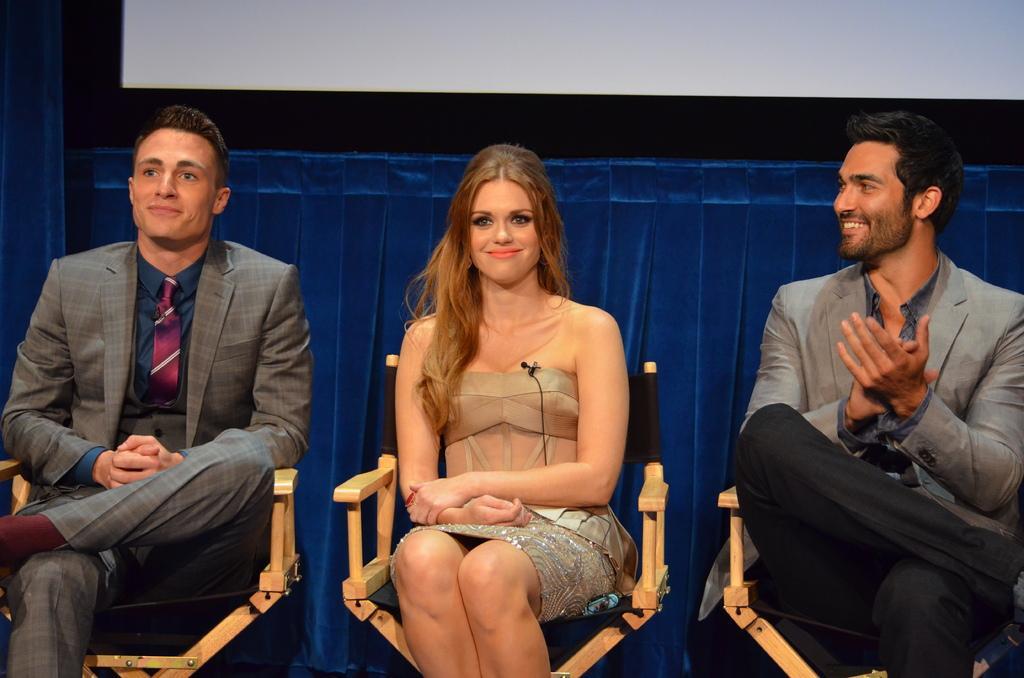Please provide a concise description of this image. In this picture there is a woman sitting in a chair and there are two persons sitting on either sides of her and there is a blue cloth behind them. 